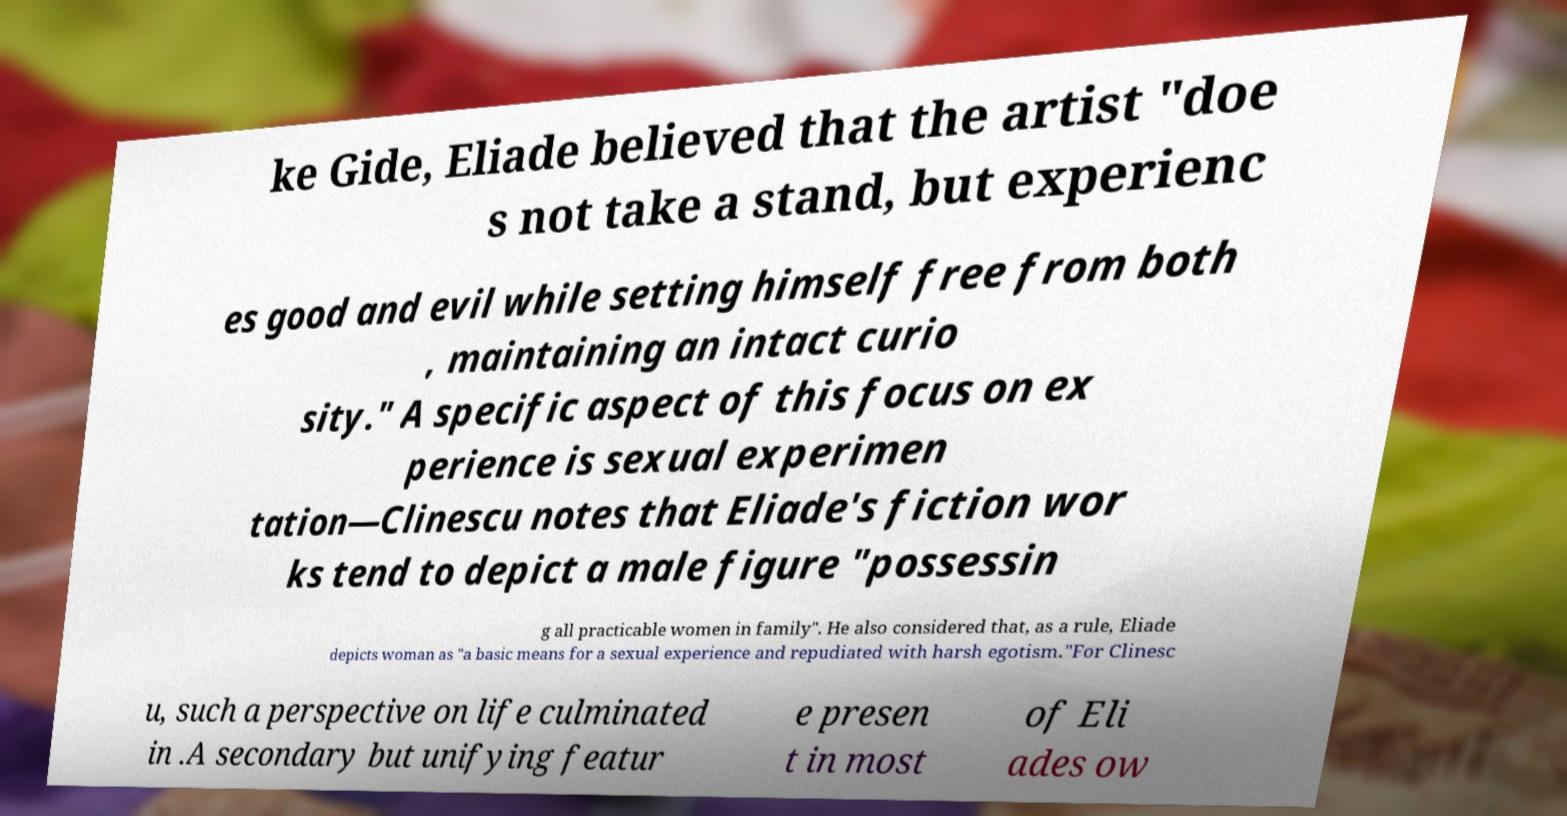Can you accurately transcribe the text from the provided image for me? ke Gide, Eliade believed that the artist "doe s not take a stand, but experienc es good and evil while setting himself free from both , maintaining an intact curio sity." A specific aspect of this focus on ex perience is sexual experimen tation—Clinescu notes that Eliade's fiction wor ks tend to depict a male figure "possessin g all practicable women in family". He also considered that, as a rule, Eliade depicts woman as "a basic means for a sexual experience and repudiated with harsh egotism."For Clinesc u, such a perspective on life culminated in .A secondary but unifying featur e presen t in most of Eli ades ow 